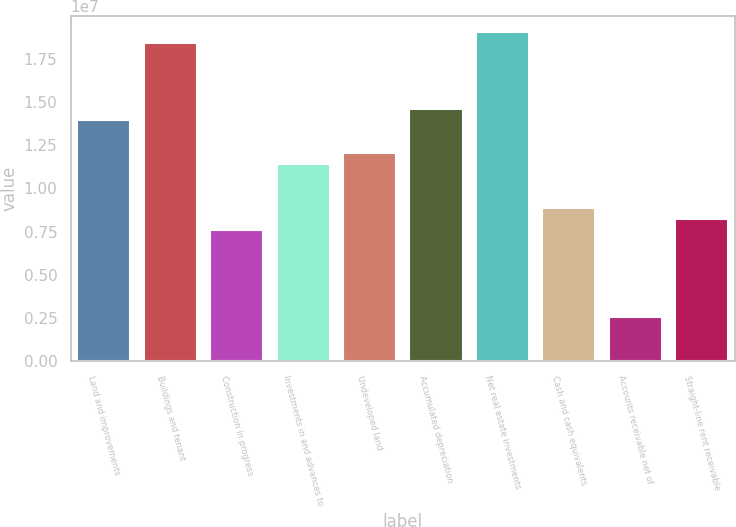<chart> <loc_0><loc_0><loc_500><loc_500><bar_chart><fcel>Land and improvements<fcel>Buildings and tenant<fcel>Construction in progress<fcel>Investments in and advances to<fcel>Undeveloped land<fcel>Accumulated depreciation<fcel>Net real estate investments<fcel>Cash and cash equivalents<fcel>Accounts receivable net of<fcel>Straight-line rent receivable<nl><fcel>1.39531e+07<fcel>1.8392e+07<fcel>7.61179e+06<fcel>1.14166e+07<fcel>1.20507e+07<fcel>1.45872e+07<fcel>1.90261e+07<fcel>8.88004e+06<fcel>2.53876e+06<fcel>8.24591e+06<nl></chart> 